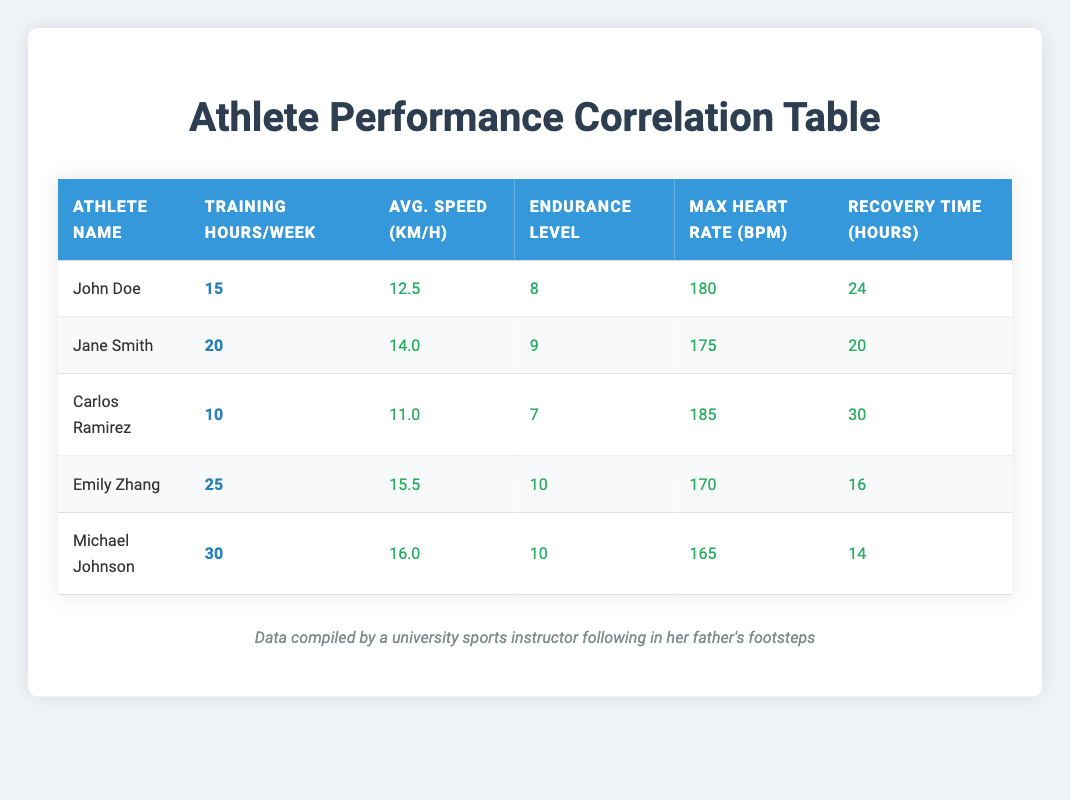What is the maximum average speed recorded among the athletes? Looking at the "Avg. Speed (km/h)" column, the highest value is 16.0 km/h corresponding to Michael Johnson.
Answer: 16.0 km/h How many training hours per week does Emily Zhang dedicate to training? From the "Training Hours/Week" column, Emily Zhang is noted to train 25 hours per week.
Answer: 25 Is Jane Smith's maximum heart rate higher than Carlos Ramirez's? Jane Smith's max heart rate is 175 bpm, while Carlos Ramirez's is 185 bpm. Since 175 < 185, the statement is false.
Answer: No What is the average endurance level of the athletes? Adding the endurance levels: (8 + 9 + 7 + 10 + 10 = 44) gives 44. There are 5 athletes, so the average is 44/5 = 8.8.
Answer: 8.8 Which athlete has the longest recovery time? Examining the "Recovery Time (hours)" column, Carlos Ramirez has a recovery time of 30 hours, which is the highest in the list.
Answer: Carlos Ramirez What is the difference in training hours per week between Michael Johnson and John Doe? Michael Johnson trains for 30 hours and John Doe for 15 hours. The difference is 30 - 15 = 15 hours.
Answer: 15 How many athletes have an endurance level of 10? There are two athletes with an endurance level of 10: Emily Zhang and Michael Johnson.
Answer: 2 Which athlete has the lowest average speed? From the "Avg. Speed (km/h)" column, Carlos Ramirez has the lowest speed at 11.0 km/h.
Answer: Carlos Ramirez What is the sum of training hours for all athletes? The training hours are: 15 + 20 + 10 + 25 + 30 = 100. Thus, the total training hours for all athletes is 100.
Answer: 100 Is it true that all athletes train more than 10 hours per week? Checking the training hours, all except Carlos Ramirez have hours greater than 10. Carlos Ramirez trains for 10 hours, making the statement false.
Answer: No 